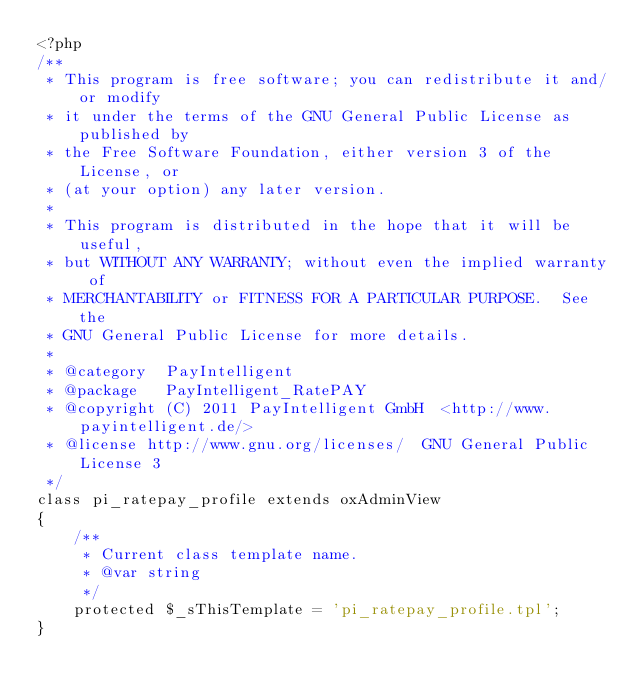Convert code to text. <code><loc_0><loc_0><loc_500><loc_500><_PHP_><?php
/**
 * This program is free software; you can redistribute it and/or modify
 * it under the terms of the GNU General Public License as published by
 * the Free Software Foundation, either version 3 of the License, or
 * (at your option) any later version.
 *
 * This program is distributed in the hope that it will be useful,
 * but WITHOUT ANY WARRANTY; without even the implied warranty of
 * MERCHANTABILITY or FITNESS FOR A PARTICULAR PURPOSE.  See the
 * GNU General Public License for more details.
 *
 * @category  PayIntelligent
 * @package   PayIntelligent_RatePAY
 * @copyright (C) 2011 PayIntelligent GmbH  <http://www.payintelligent.de/>
 * @license	http://www.gnu.org/licenses/  GNU General Public License 3
 */
class pi_ratepay_profile extends oxAdminView
{
    /**
     * Current class template name.
     * @var string
     */
    protected $_sThisTemplate = 'pi_ratepay_profile.tpl';
}</code> 